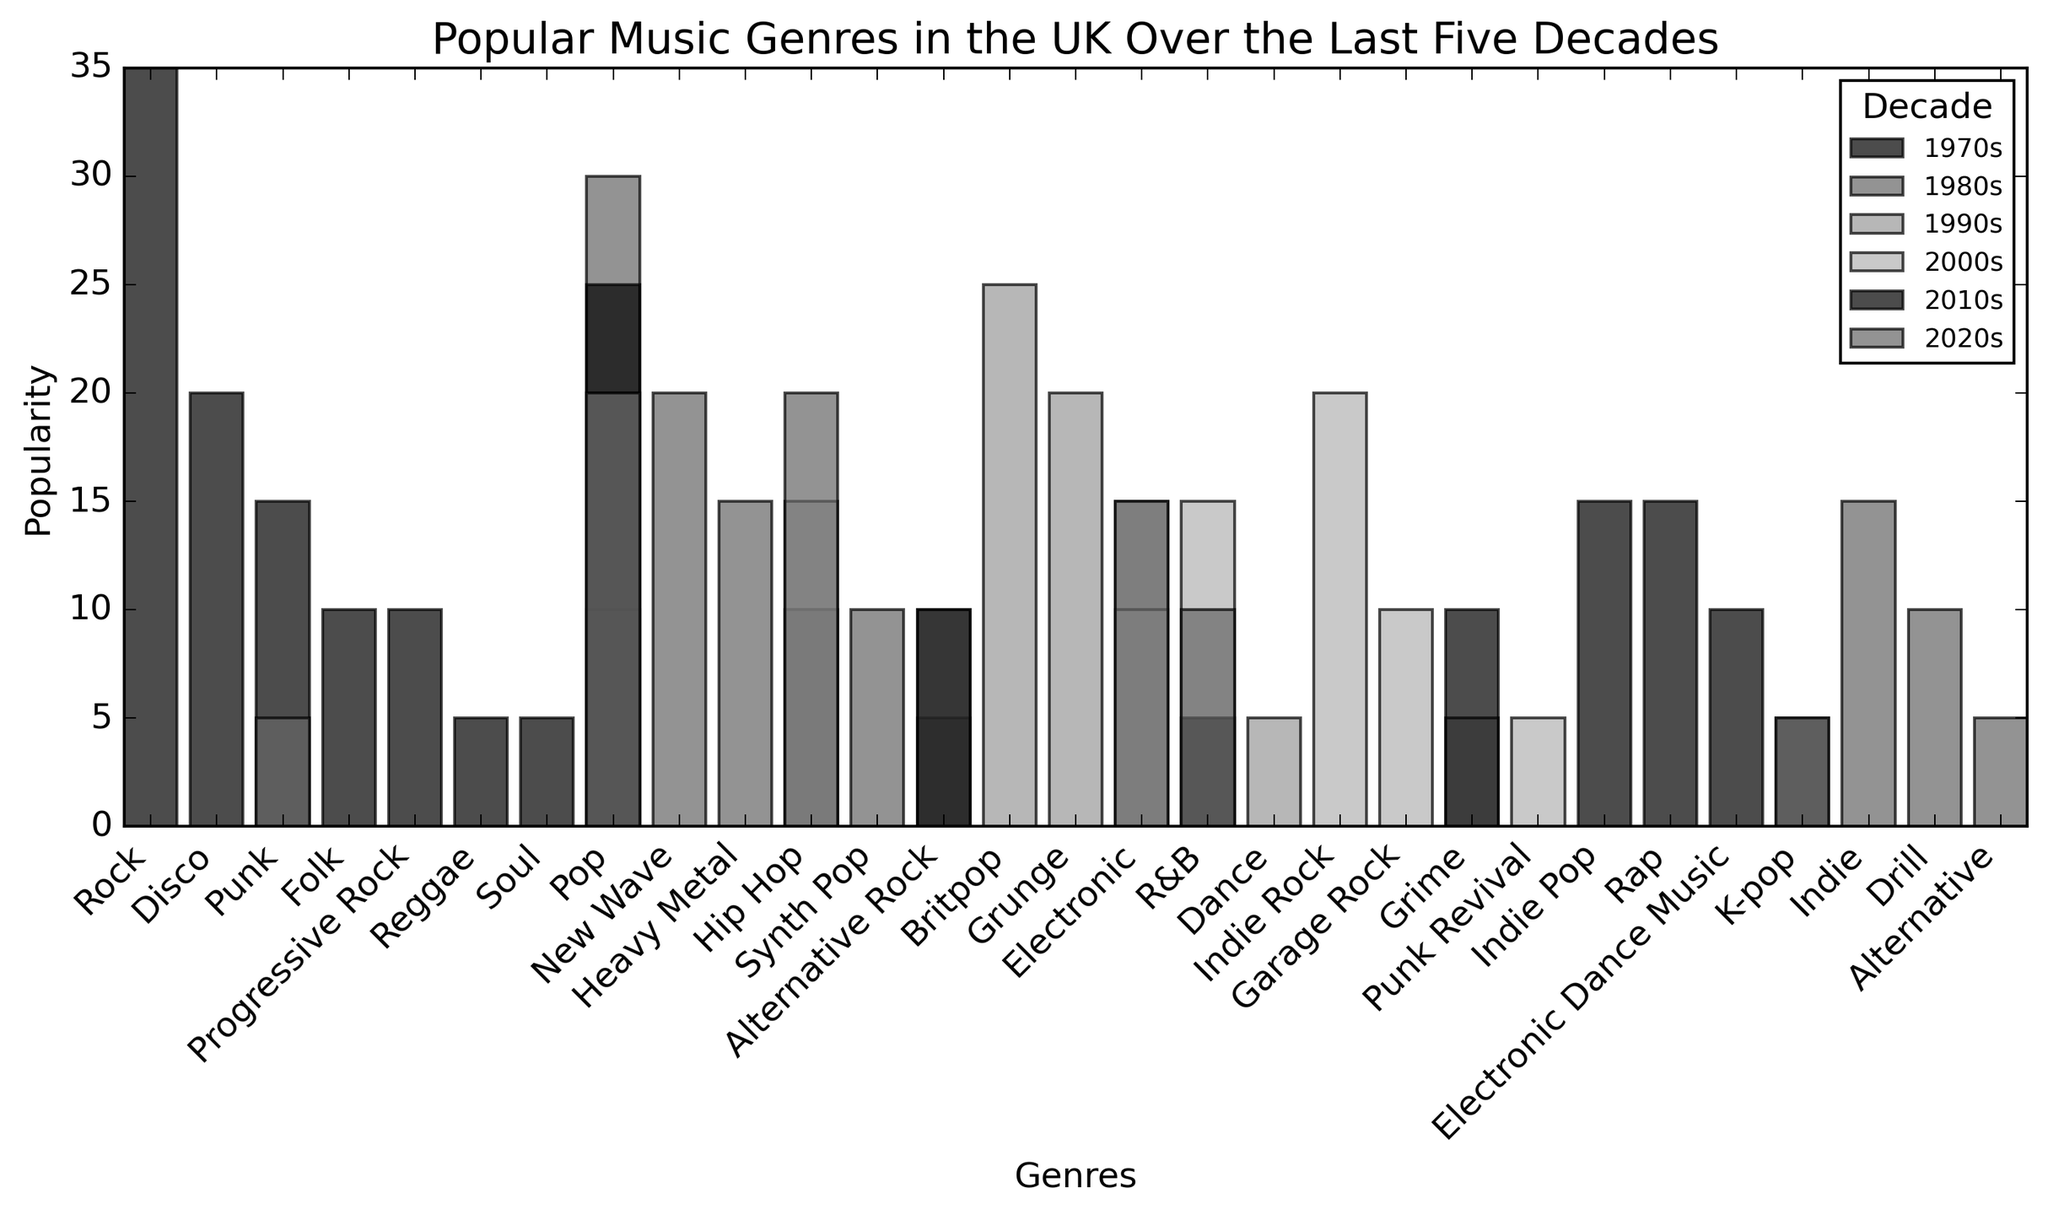Which genre was the most popular in the 1970s? By examining the heights of the bars for the 1970s, we see that the bar for Rock is the tallest, indicating it's the most popular genre.
Answer: Rock Which decade had the highest popularity for Pop music? Look at the bars for Pop music across all decades. The 1980s bar is the tallest for Pop, indicating it has the highest popularity in that decade.
Answer: 1980s Which genres appeared in multiple decades? Visually scan the bars to see which genres appear in more than one decade. Pop, Hip Hop, and R&B are among those present in multiple decades.
Answer: Pop, Hip Hop, R&B What was the total popularity of Electronic music across all decades? Sum the heights of the bars for Electronic music in the 1990s (15), 2000s (10), 2010s (10), and 2020s (15). The total is 15 + 10 + 10 + 15 = 50.
Answer: 50 Which genre saw an increase in popularity from the 1980s to the 1990s? Compare the heights of bars for each genre between the 1980s and 1990s. Hip Hop increased from 10 in the 1980s to 10 in the 1990s.
Answer: Hip Hop In which decade was Alternative Rock most popular? Look at the heights of the bars for Alternative Rock across all decades. The highest bar for Alternative Rock is in the 1980s.
Answer: 1980s What is the difference in popularity between the most and least popular genres in the 2010s? Identify the tallest (Pop, 25) and shortest (K-pop and R&B, 5 each) bars in the 2010s, and subtract the shortest from the tallest: 25 - 5 = 20.
Answer: 20 Which genre had the highest average popularity over the decades? Calculate the average popularity of each genre across all its appearances in the decades. Pop, appearing multiple times (30+10+10+20+20)/5 is comparable to other averages. After calculating, Pop has the highest average.
Answer: Pop Which genre's popularity remained constant over two consecutive decades? Check the bars for genres appearing in consecutive decades and see if their heights remain unchanged. R&B had 5 in the 1990s and 5 in the 2010s.
Answer: R&B How did the popularity of Indie-related genres change from the 2000s to the 2010s? Compare the bars for Indie Rock in the 2000s (20) and Indie Pop in the 2010s (15). The popularity slightly decreased from 20 to 15.
Answer: Decreased 